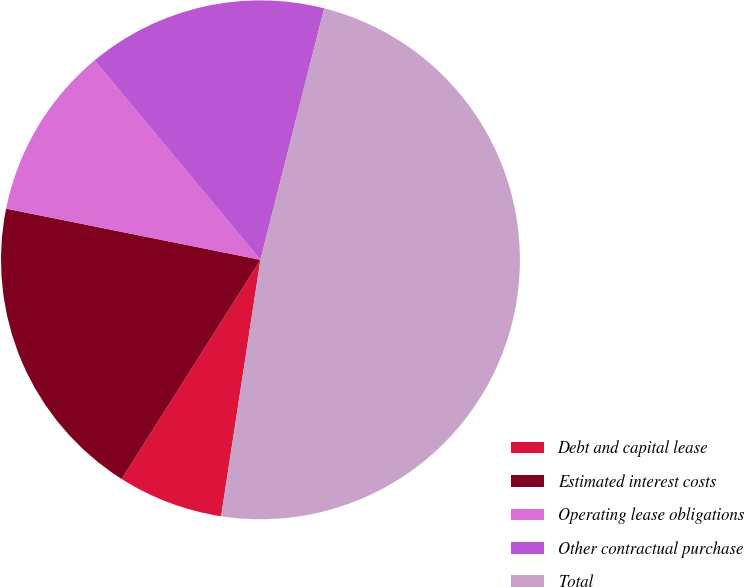Convert chart. <chart><loc_0><loc_0><loc_500><loc_500><pie_chart><fcel>Debt and capital lease<fcel>Estimated interest costs<fcel>Operating lease obligations<fcel>Other contractual purchase<fcel>Total<nl><fcel>6.56%<fcel>19.18%<fcel>10.8%<fcel>14.99%<fcel>48.47%<nl></chart> 